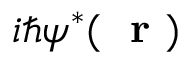<formula> <loc_0><loc_0><loc_500><loc_500>i \hbar { \psi } ^ { * } ( r )</formula> 